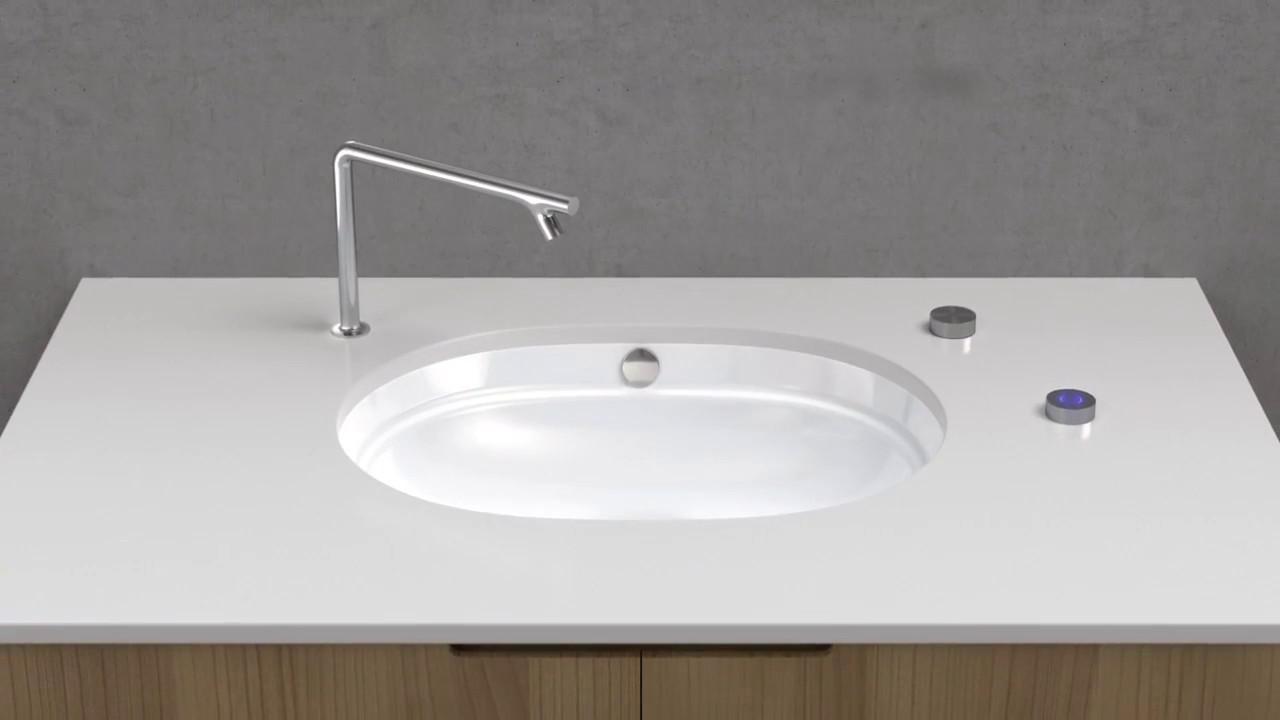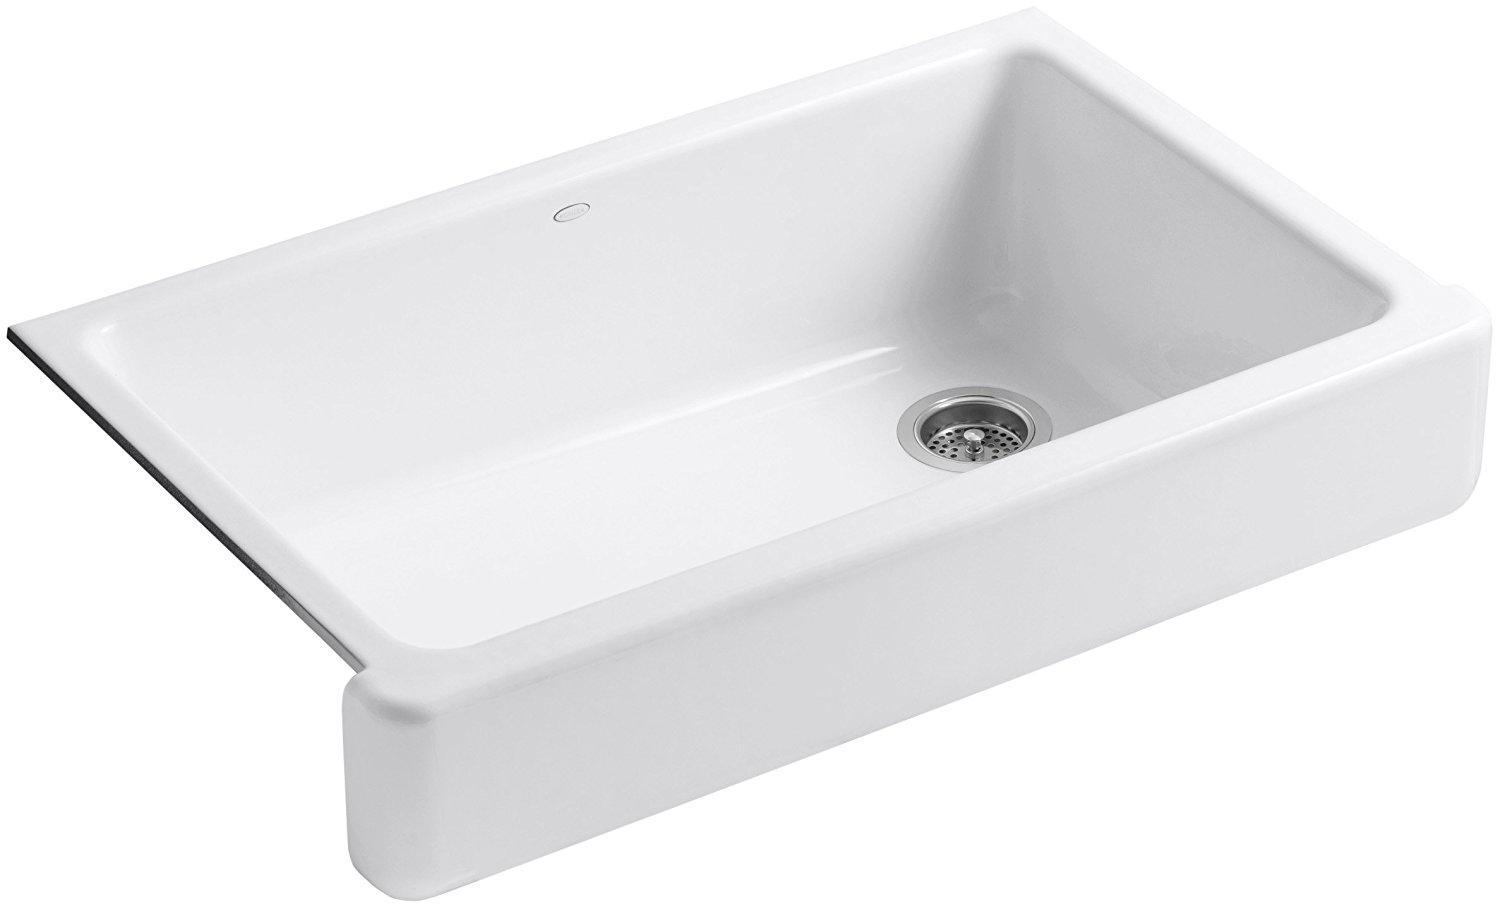The first image is the image on the left, the second image is the image on the right. Assess this claim about the two images: "the sinks is square in the right pic". Correct or not? Answer yes or no. Yes. 